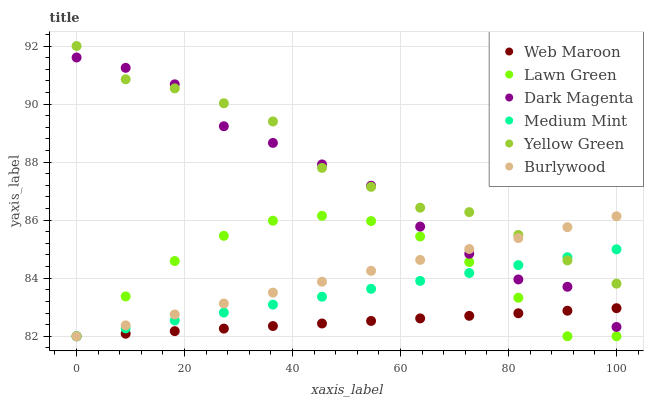Does Web Maroon have the minimum area under the curve?
Answer yes or no. Yes. Does Yellow Green have the maximum area under the curve?
Answer yes or no. Yes. Does Lawn Green have the minimum area under the curve?
Answer yes or no. No. Does Lawn Green have the maximum area under the curve?
Answer yes or no. No. Is Medium Mint the smoothest?
Answer yes or no. Yes. Is Dark Magenta the roughest?
Answer yes or no. Yes. Is Lawn Green the smoothest?
Answer yes or no. No. Is Lawn Green the roughest?
Answer yes or no. No. Does Medium Mint have the lowest value?
Answer yes or no. Yes. Does Dark Magenta have the lowest value?
Answer yes or no. No. Does Yellow Green have the highest value?
Answer yes or no. Yes. Does Lawn Green have the highest value?
Answer yes or no. No. Is Web Maroon less than Yellow Green?
Answer yes or no. Yes. Is Yellow Green greater than Lawn Green?
Answer yes or no. Yes. Does Medium Mint intersect Dark Magenta?
Answer yes or no. Yes. Is Medium Mint less than Dark Magenta?
Answer yes or no. No. Is Medium Mint greater than Dark Magenta?
Answer yes or no. No. Does Web Maroon intersect Yellow Green?
Answer yes or no. No. 